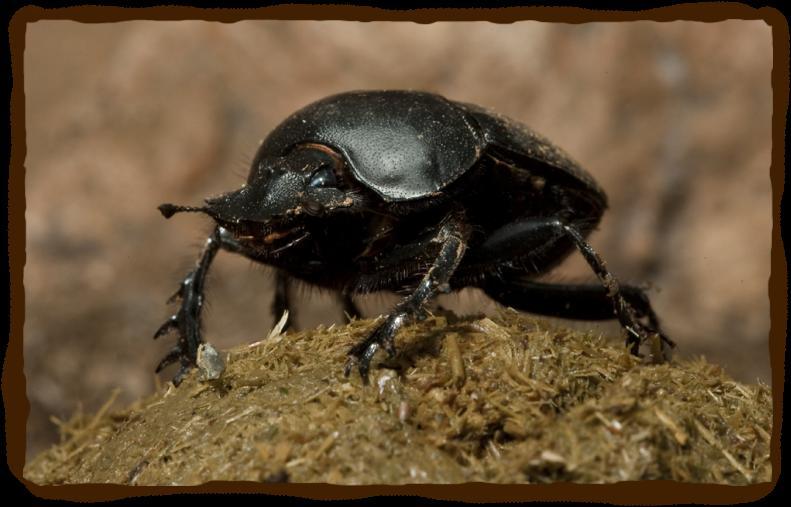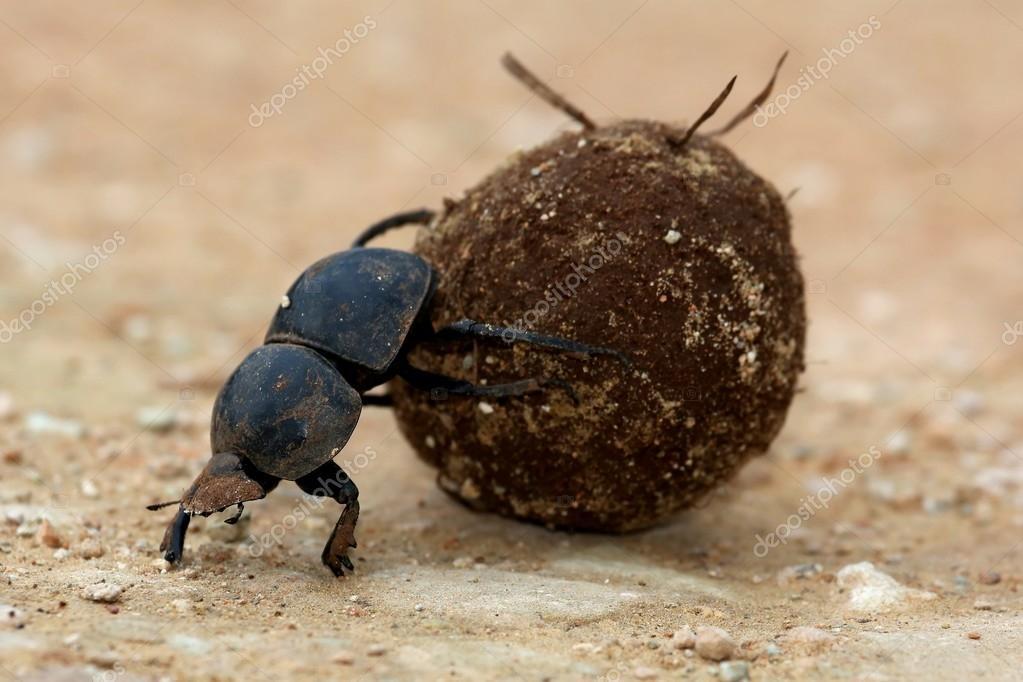The first image is the image on the left, the second image is the image on the right. Examine the images to the left and right. Is the description "A beetle is perched on a ball with its front legs touching the ground on the right side of the image." accurate? Answer yes or no. No. 